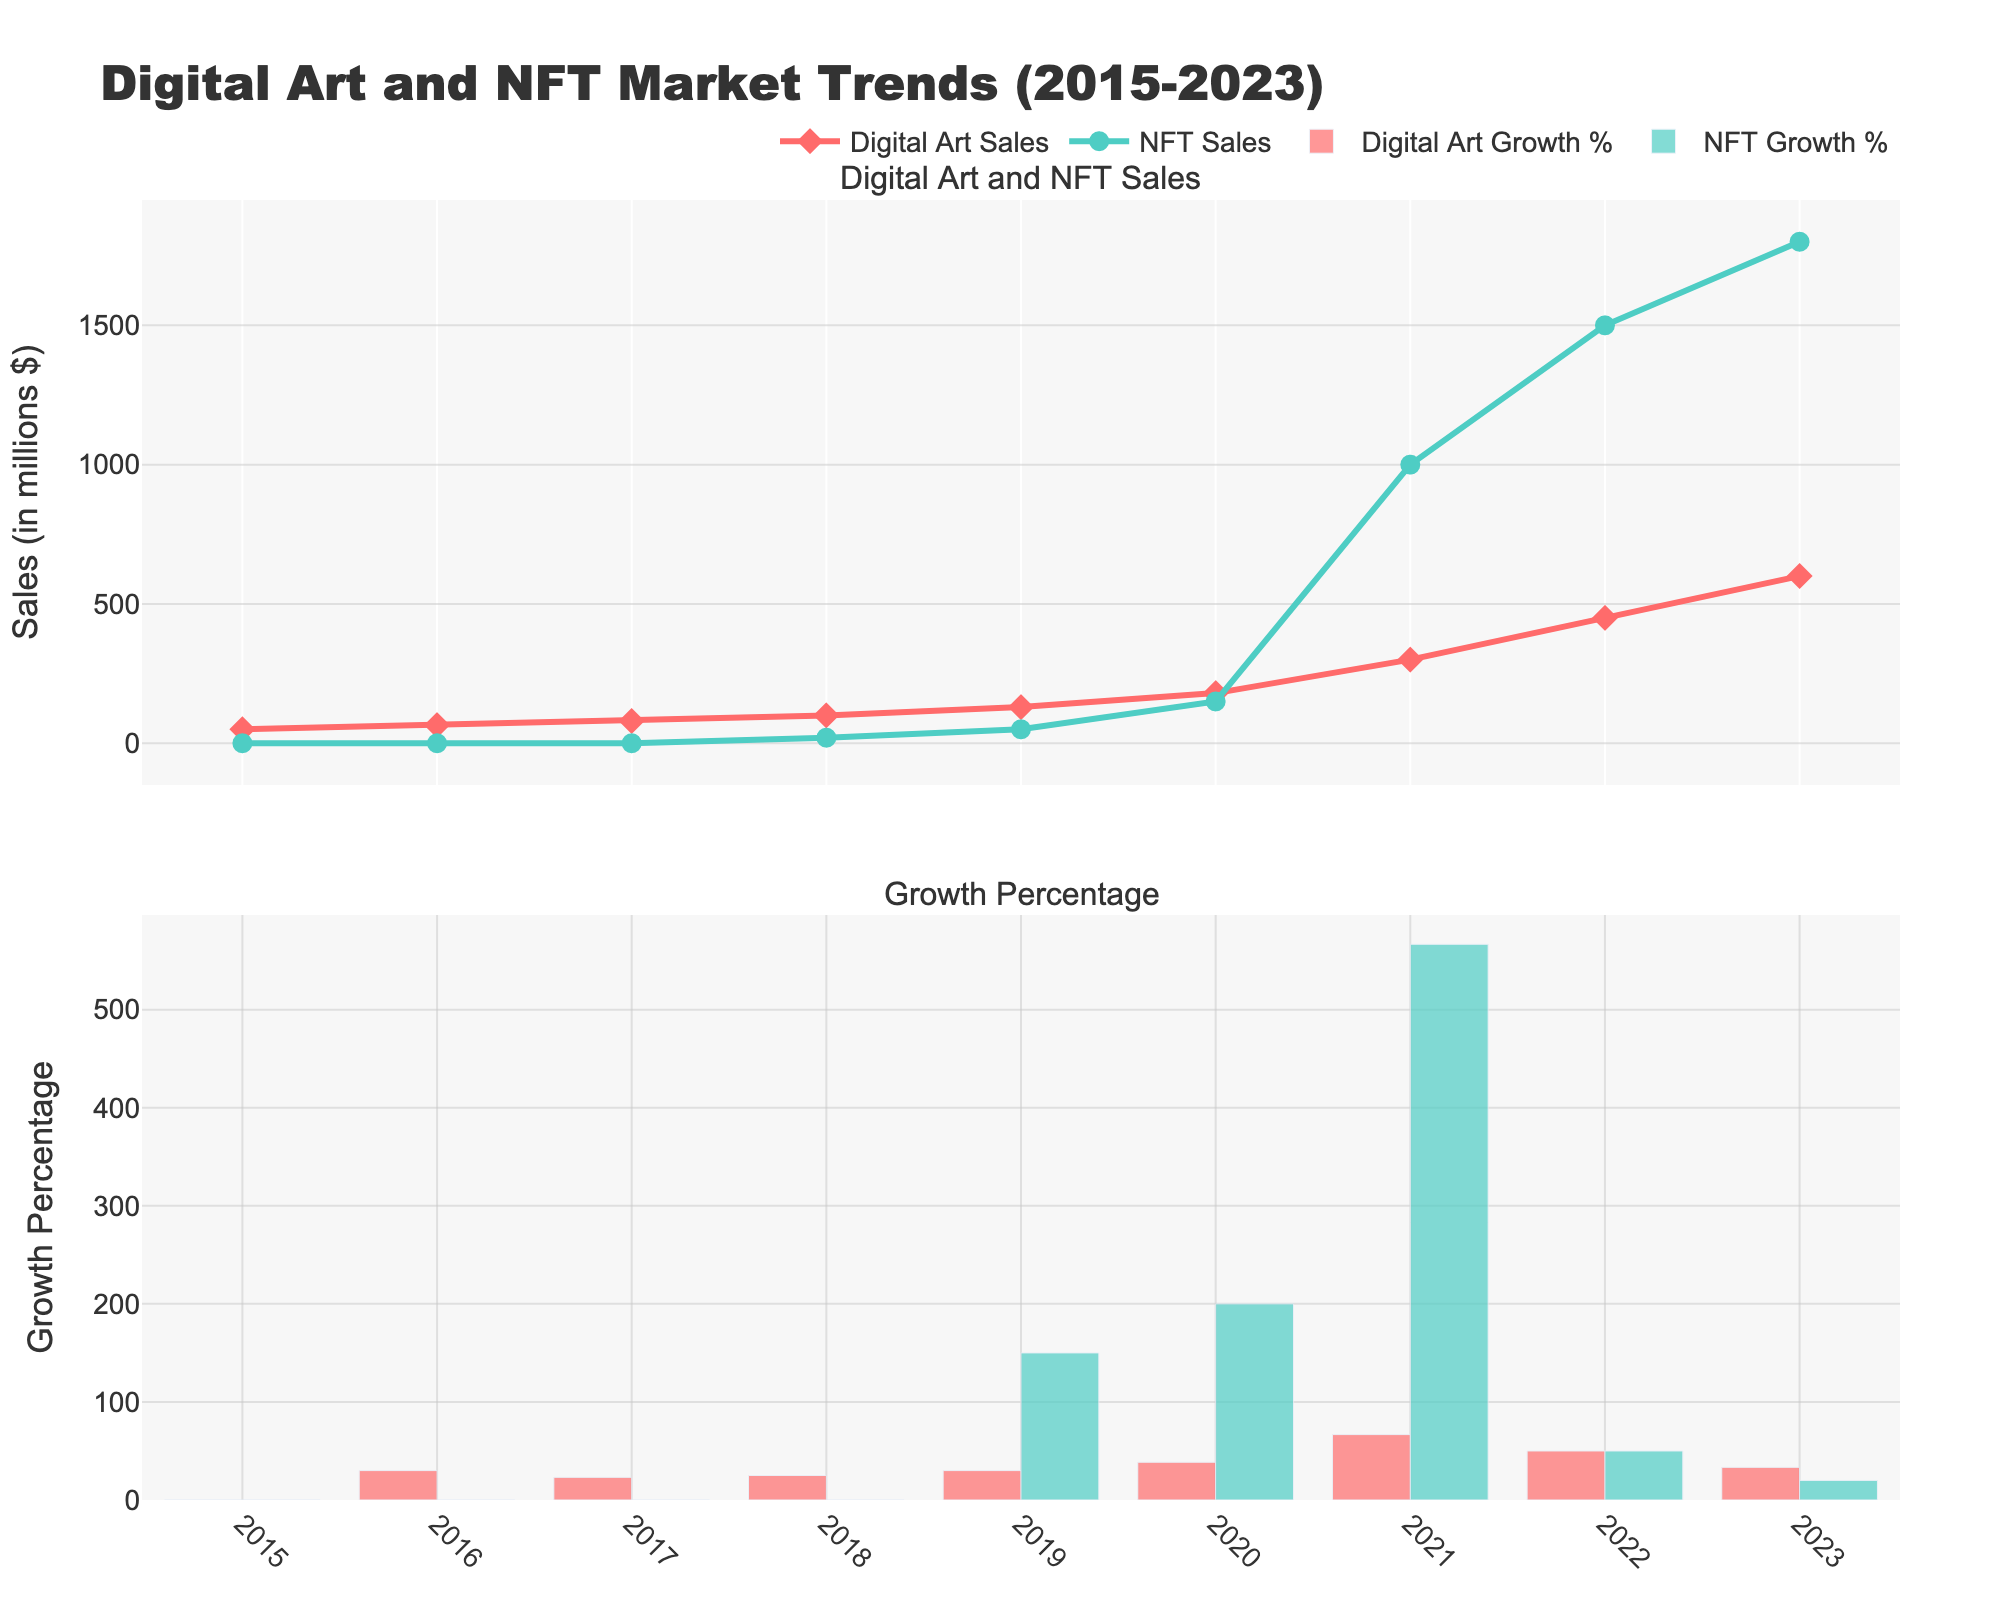What is the title of the figure? The title is displayed at the top of the figure.
Answer: Digital Art and NFT Market Trends (2015-2023) How many years of data are presented in the figure? The x-axis lists the years from 2015 to 2023. Counting these years, there are 9 data points.
Answer: 9 Which year had the highest Digital Art Sales? Digital Art Sales are represented by the red line and markers. By following the red markers up to the y-axis, it is clear that 2023, with a value of 600 million dollars, is the highest.
Answer: 2023 How did the NFT Sales Growth Percentage change from 2019 to 2020? The lower subplot shows NFT Sales Growth Percentage with green bars. Comparing the height of the bars for 2019 (150%) and 2020 (200%), the growth percentage increased by 50%.
Answer: Increased by 50% Which year experienced the highest growth percentage in NFT Sales? By examining the heights of the green bars in the lower subplot, the 2021 bar is the tallest, indicating the highest growth percentage of 566.7%.
Answer: 2021 How does the growth in Digital Art Sales in 2022 compare to the previous year? The lower subplot shows Digital Art Growth Percentage in red bars. In 2021, growth was 66.7%; in 2022, it was 50%. The growth rate decreased by 16.7 percentage points.
Answer: Decreased by 16.7% Compare the Digital Art Sales and NFT Sales in 2018. By comparing the heights of the red and green lines in 2018, Digital Art Sales were 100 million dollars, and NFT Sales were 20 million dollars. Digital Art Sales were significantly higher.
Answer: Digital Art Sales were higher What was the average Digital Art Sales Growth Percentage from 2015 to 2023? Sum the growth percentages (0, 30, 23.1, 25, 30, 38.5, 66.7, 50, 33.3) and divide by the number of years: (296.6 / 9) ≈ 33%.
Answer: Approximately 33% By how much did Digital Art Sales increase from 2015 to 2023? Digital Art Sales in 2015 were 50 million dollars and in 2023 were 600 million dollars. The increase is 600 - 50 = 550 million dollars.
Answer: 550 million dollars In which year did NFT Sales begin to be recorded in the figure? By examining the green markers in the upper subplot, NFT Sales start in 2018 with 20 million dollars.
Answer: 2018 